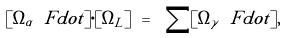Convert formula to latex. <formula><loc_0><loc_0><loc_500><loc_500>[ \Omega _ { \alpha } \ F d o t ] \cdot [ \Omega _ { L } ] \ = \ \sum [ \Omega _ { \gamma } \ F d o t ] ,</formula> 